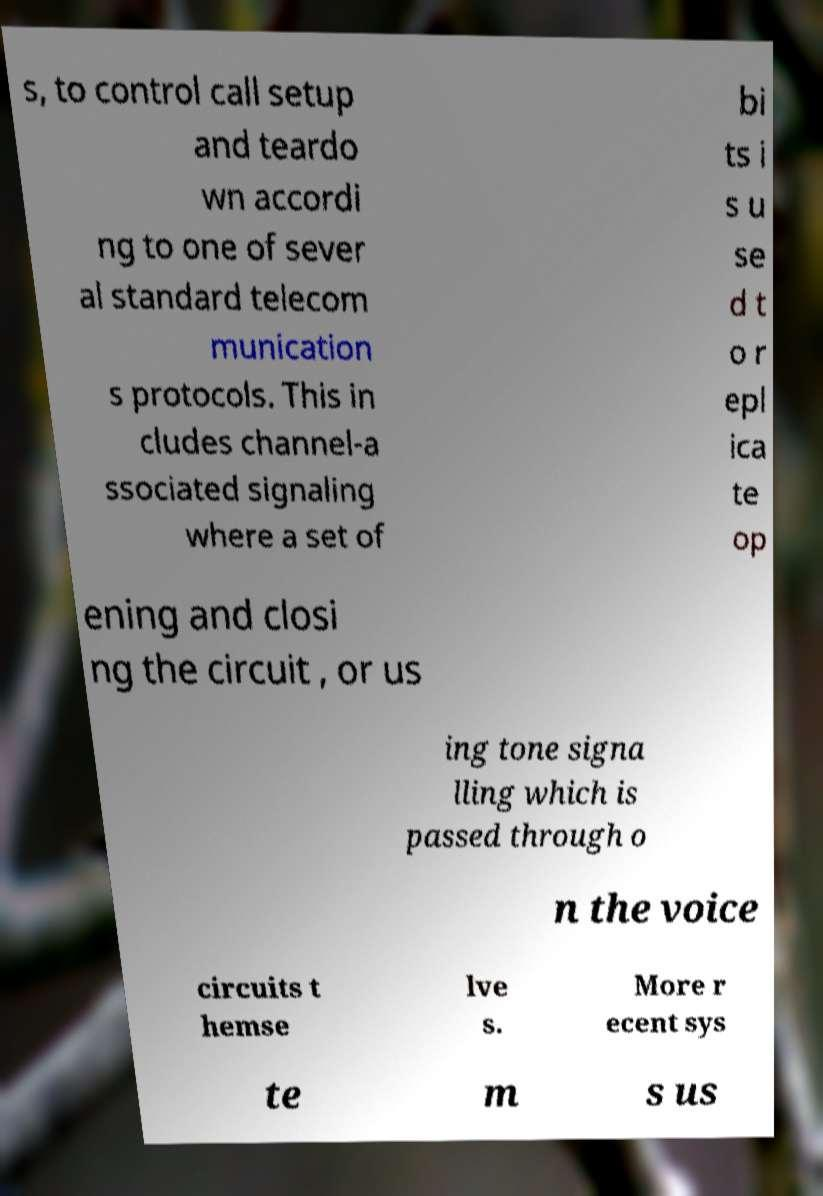Please read and relay the text visible in this image. What does it say? s, to control call setup and teardo wn accordi ng to one of sever al standard telecom munication s protocols. This in cludes channel-a ssociated signaling where a set of bi ts i s u se d t o r epl ica te op ening and closi ng the circuit , or us ing tone signa lling which is passed through o n the voice circuits t hemse lve s. More r ecent sys te m s us 